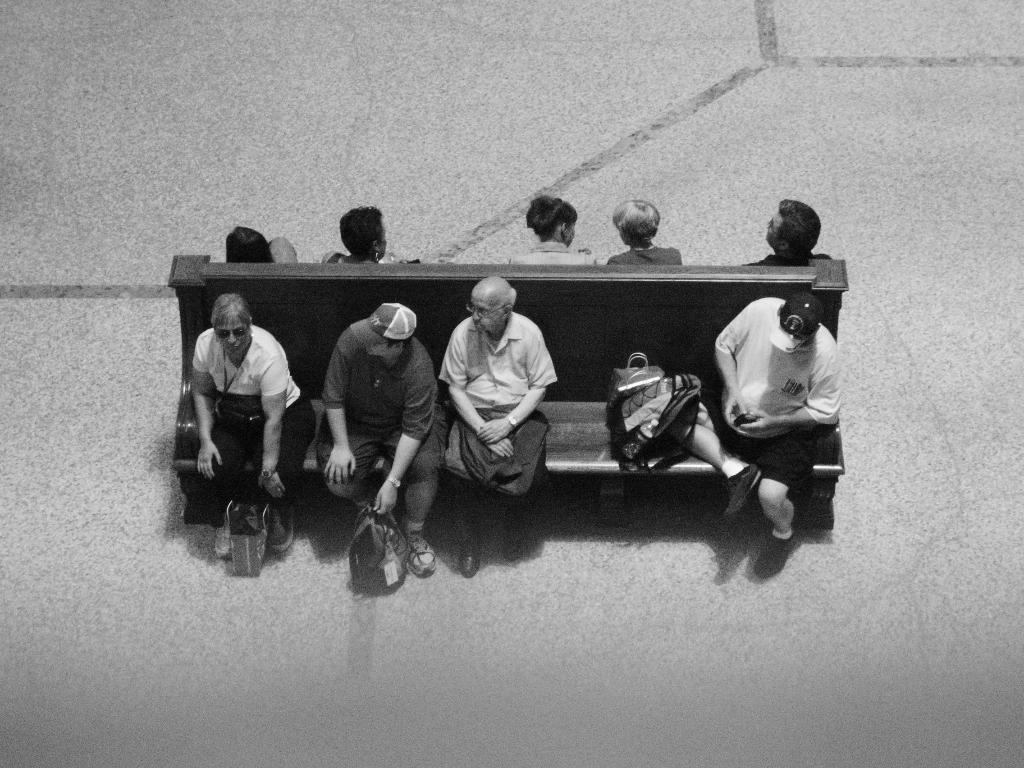What are the people in the image doing? The people in the image are sitting on a bench. What else can be seen on the bench besides the people? There are bags visible on the bench. Is there anything else related to bags in the image? Yes, there is a bag on the path in the image. What type of notebook is being used by the people sitting on the bench in the image? There is no notebook present in the image; the people are sitting on a bench with bags. 